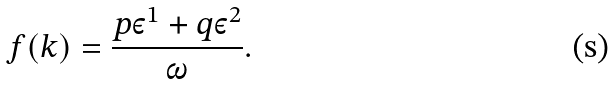<formula> <loc_0><loc_0><loc_500><loc_500>f ( k ) = \frac { p \varepsilon ^ { 1 } + q \varepsilon ^ { 2 } } { \omega } .</formula> 